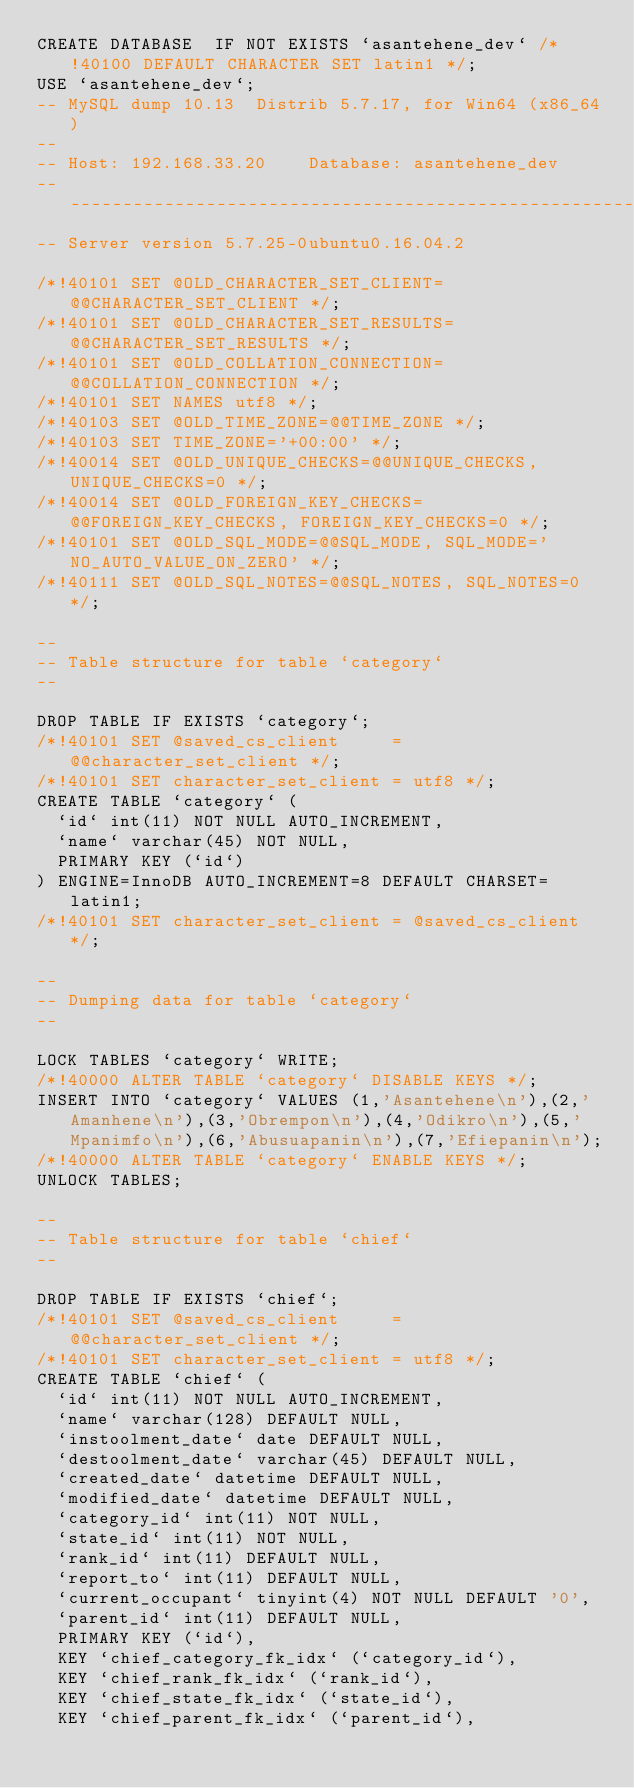Convert code to text. <code><loc_0><loc_0><loc_500><loc_500><_SQL_>CREATE DATABASE  IF NOT EXISTS `asantehene_dev` /*!40100 DEFAULT CHARACTER SET latin1 */;
USE `asantehene_dev`;
-- MySQL dump 10.13  Distrib 5.7.17, for Win64 (x86_64)
--
-- Host: 192.168.33.20    Database: asantehene_dev
-- ------------------------------------------------------
-- Server version	5.7.25-0ubuntu0.16.04.2

/*!40101 SET @OLD_CHARACTER_SET_CLIENT=@@CHARACTER_SET_CLIENT */;
/*!40101 SET @OLD_CHARACTER_SET_RESULTS=@@CHARACTER_SET_RESULTS */;
/*!40101 SET @OLD_COLLATION_CONNECTION=@@COLLATION_CONNECTION */;
/*!40101 SET NAMES utf8 */;
/*!40103 SET @OLD_TIME_ZONE=@@TIME_ZONE */;
/*!40103 SET TIME_ZONE='+00:00' */;
/*!40014 SET @OLD_UNIQUE_CHECKS=@@UNIQUE_CHECKS, UNIQUE_CHECKS=0 */;
/*!40014 SET @OLD_FOREIGN_KEY_CHECKS=@@FOREIGN_KEY_CHECKS, FOREIGN_KEY_CHECKS=0 */;
/*!40101 SET @OLD_SQL_MODE=@@SQL_MODE, SQL_MODE='NO_AUTO_VALUE_ON_ZERO' */;
/*!40111 SET @OLD_SQL_NOTES=@@SQL_NOTES, SQL_NOTES=0 */;

--
-- Table structure for table `category`
--

DROP TABLE IF EXISTS `category`;
/*!40101 SET @saved_cs_client     = @@character_set_client */;
/*!40101 SET character_set_client = utf8 */;
CREATE TABLE `category` (
  `id` int(11) NOT NULL AUTO_INCREMENT,
  `name` varchar(45) NOT NULL,
  PRIMARY KEY (`id`)
) ENGINE=InnoDB AUTO_INCREMENT=8 DEFAULT CHARSET=latin1;
/*!40101 SET character_set_client = @saved_cs_client */;

--
-- Dumping data for table `category`
--

LOCK TABLES `category` WRITE;
/*!40000 ALTER TABLE `category` DISABLE KEYS */;
INSERT INTO `category` VALUES (1,'Asantehene\n'),(2,'Amanhene\n'),(3,'Obrempon\n'),(4,'Odikro\n'),(5,'Mpanimfo\n'),(6,'Abusuapanin\n'),(7,'Efiepanin\n');
/*!40000 ALTER TABLE `category` ENABLE KEYS */;
UNLOCK TABLES;

--
-- Table structure for table `chief`
--

DROP TABLE IF EXISTS `chief`;
/*!40101 SET @saved_cs_client     = @@character_set_client */;
/*!40101 SET character_set_client = utf8 */;
CREATE TABLE `chief` (
  `id` int(11) NOT NULL AUTO_INCREMENT,
  `name` varchar(128) DEFAULT NULL,
  `instoolment_date` date DEFAULT NULL,
  `destoolment_date` varchar(45) DEFAULT NULL,
  `created_date` datetime DEFAULT NULL,
  `modified_date` datetime DEFAULT NULL,
  `category_id` int(11) NOT NULL,
  `state_id` int(11) NOT NULL,
  `rank_id` int(11) DEFAULT NULL,
  `report_to` int(11) DEFAULT NULL,
  `current_occupant` tinyint(4) NOT NULL DEFAULT '0',
  `parent_id` int(11) DEFAULT NULL,
  PRIMARY KEY (`id`),
  KEY `chief_category_fk_idx` (`category_id`),
  KEY `chief_rank_fk_idx` (`rank_id`),
  KEY `chief_state_fk_idx` (`state_id`),
  KEY `chief_parent_fk_idx` (`parent_id`),</code> 